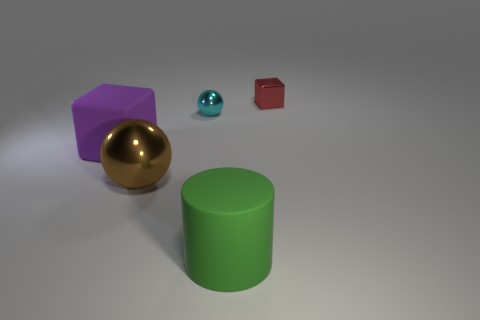Is there any other thing that has the same shape as the green thing?
Offer a very short reply. No. There is a large thing in front of the ball that is in front of the tiny cyan ball; what shape is it?
Keep it short and to the point. Cylinder. What shape is the big purple thing that is made of the same material as the big cylinder?
Offer a very short reply. Cube. There is a rubber thing behind the big rubber thing to the right of the rubber cube; what size is it?
Your response must be concise. Large. There is a big purple object; what shape is it?
Your response must be concise. Cube. How many large things are green rubber objects or cyan things?
Your answer should be compact. 1. What size is the other metallic object that is the same shape as the tiny cyan metal thing?
Keep it short and to the point. Large. What number of objects are right of the green matte cylinder and in front of the big brown object?
Offer a terse response. 0. There is a big brown object; is it the same shape as the tiny shiny thing in front of the tiny red shiny cube?
Offer a terse response. Yes. Are there more small metal objects to the left of the large brown thing than cyan metal objects?
Provide a succinct answer. No. 